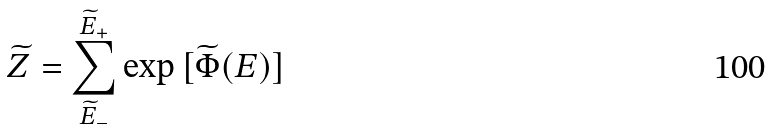<formula> <loc_0><loc_0><loc_500><loc_500>\widetilde { Z } = \sum _ { \widetilde { E } _ { - } } ^ { \widetilde { E } _ { + } } \exp { [ \widetilde { \Phi } ( E ) ] }</formula> 